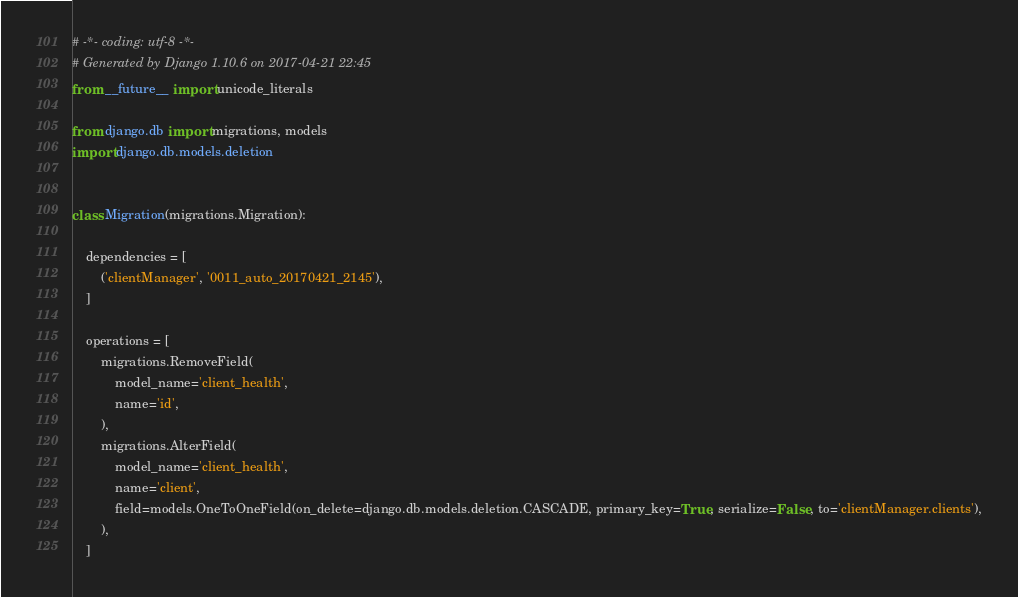Convert code to text. <code><loc_0><loc_0><loc_500><loc_500><_Python_># -*- coding: utf-8 -*-
# Generated by Django 1.10.6 on 2017-04-21 22:45
from __future__ import unicode_literals

from django.db import migrations, models
import django.db.models.deletion


class Migration(migrations.Migration):

    dependencies = [
        ('clientManager', '0011_auto_20170421_2145'),
    ]

    operations = [
        migrations.RemoveField(
            model_name='client_health',
            name='id',
        ),
        migrations.AlterField(
            model_name='client_health',
            name='client',
            field=models.OneToOneField(on_delete=django.db.models.deletion.CASCADE, primary_key=True, serialize=False, to='clientManager.clients'),
        ),
    ]
</code> 